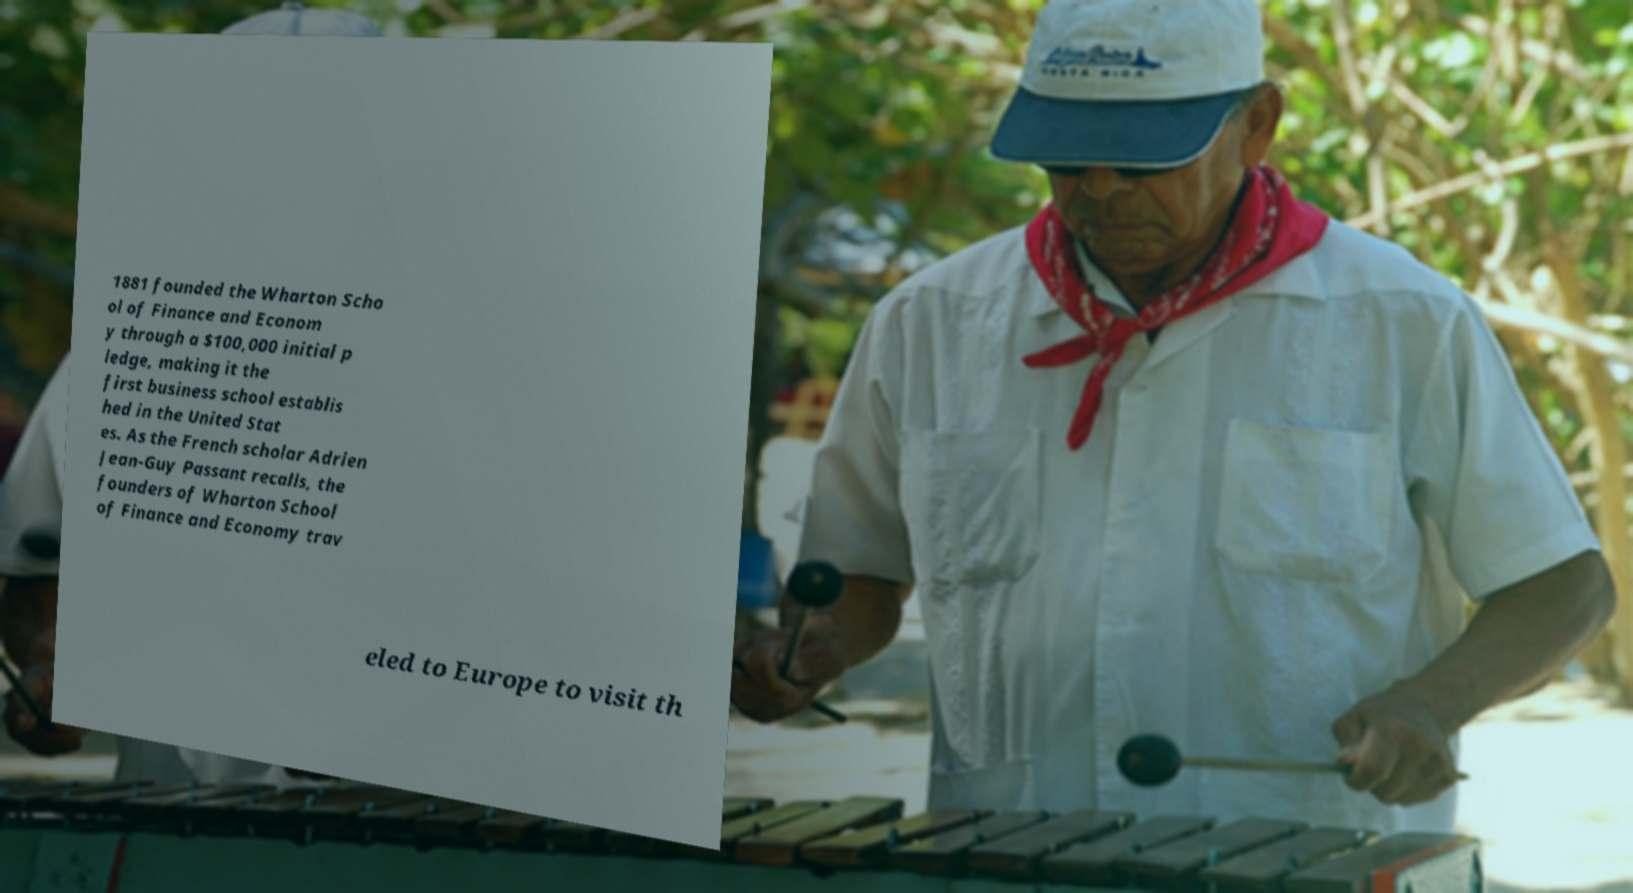Could you assist in decoding the text presented in this image and type it out clearly? 1881 founded the Wharton Scho ol of Finance and Econom y through a $100,000 initial p ledge, making it the first business school establis hed in the United Stat es. As the French scholar Adrien Jean-Guy Passant recalls, the founders of Wharton School of Finance and Economy trav eled to Europe to visit th 